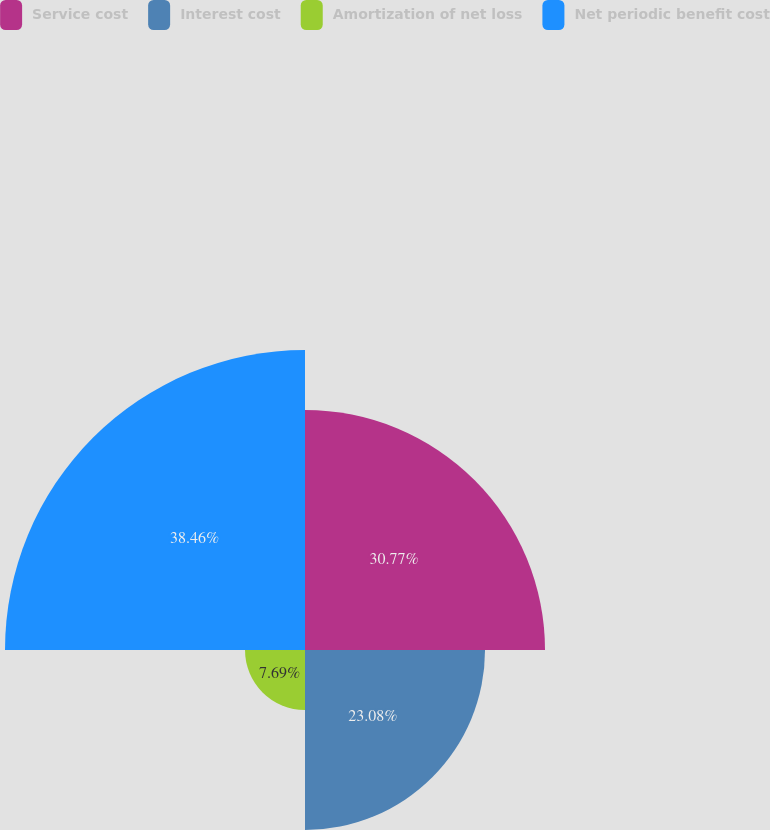<chart> <loc_0><loc_0><loc_500><loc_500><pie_chart><fcel>Service cost<fcel>Interest cost<fcel>Amortization of net loss<fcel>Net periodic benefit cost<nl><fcel>30.77%<fcel>23.08%<fcel>7.69%<fcel>38.46%<nl></chart> 